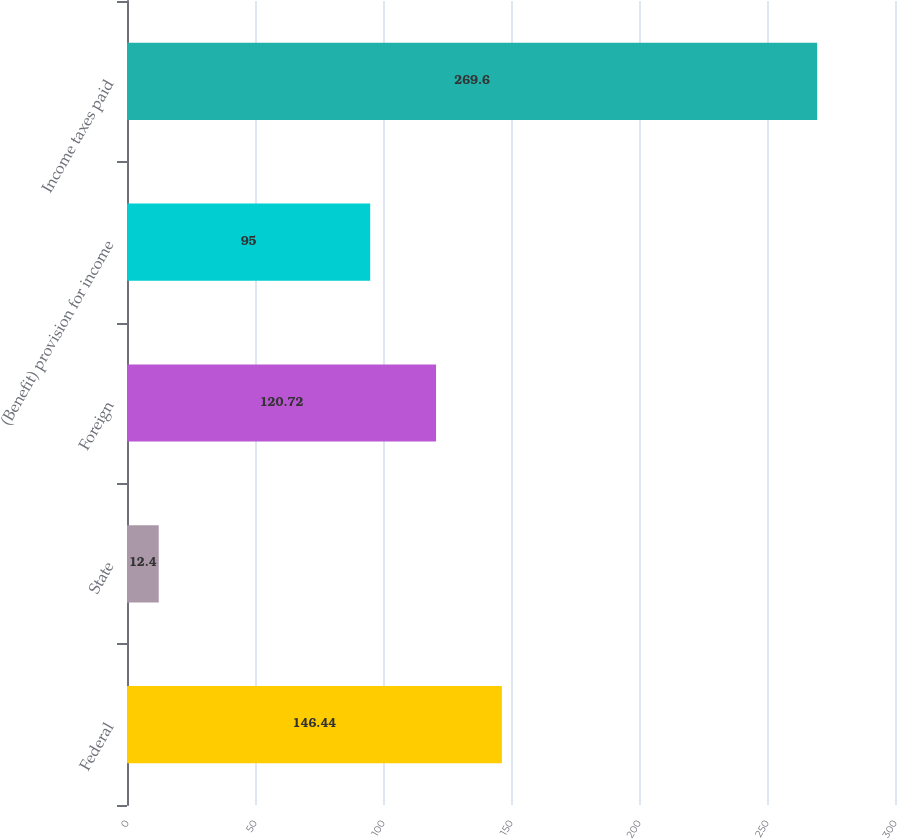Convert chart. <chart><loc_0><loc_0><loc_500><loc_500><bar_chart><fcel>Federal<fcel>State<fcel>Foreign<fcel>(Benefit) provision for income<fcel>Income taxes paid<nl><fcel>146.44<fcel>12.4<fcel>120.72<fcel>95<fcel>269.6<nl></chart> 